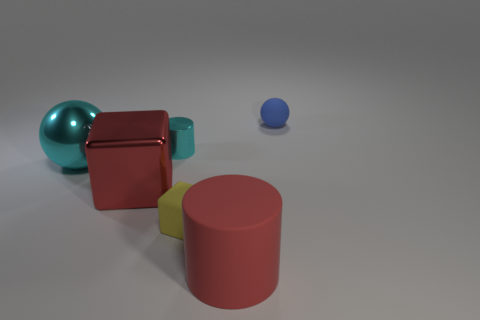What could this arrangement of shapes represent, if we were to interpret it more abstractly? Interpreting the arrangement abstractly, it might evoke the idea of order and balance, as the shapes are neatly spaced and their positioning is deliberate. The distinct textures and colors could represent diversity or individuality. The overall simplicity and clarity might suggest a theme of minimalism or focus. What do the different textures suggest about the items? The contrasting textures, such as the smooth metallic surface of the balls and the matte finish of the other shapes, suggest a diversity of materials and tactile experiences. They invite viewers to imagine how each object might feel and interact with light differently, possibly alluding to an underlying theme of sensory perception or the juxtaposition between the natural and the artificial. 